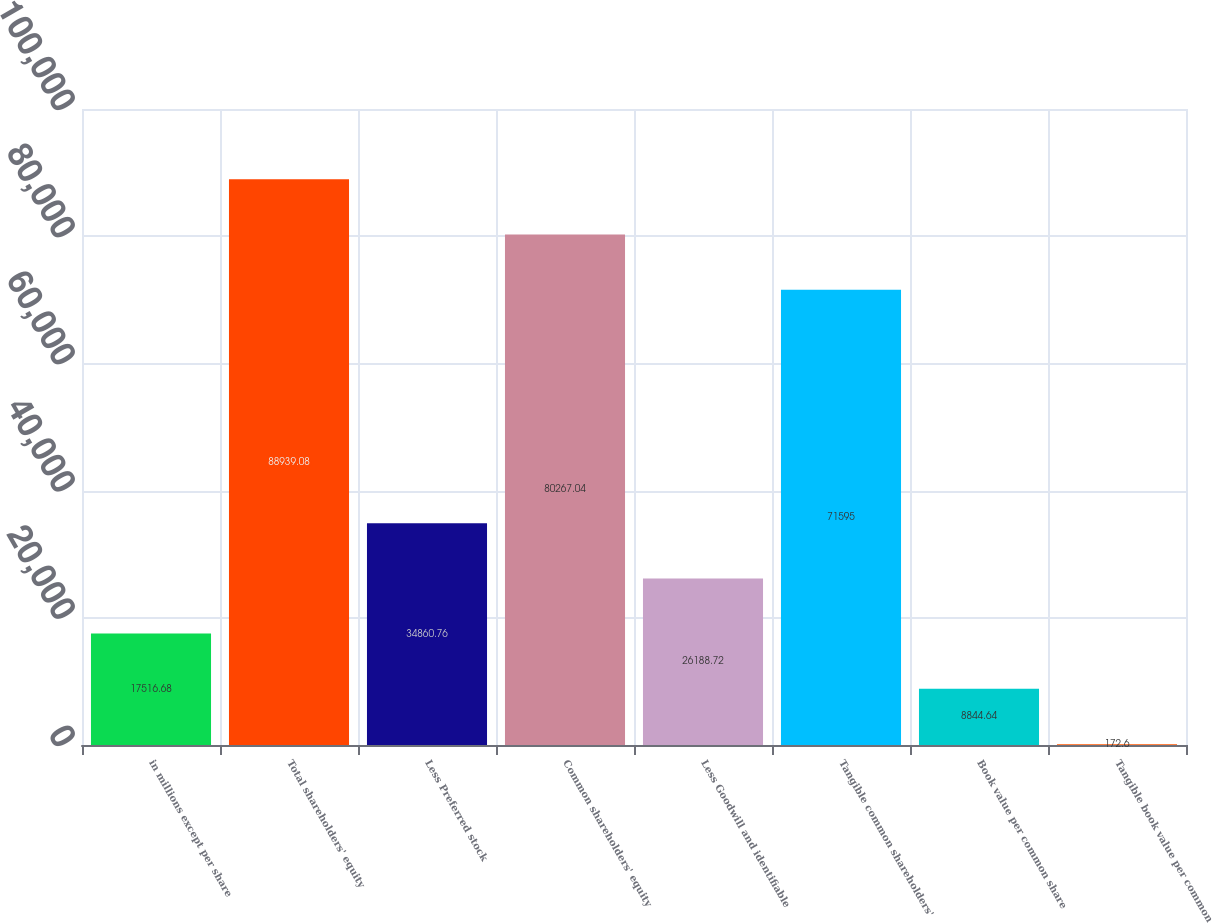Convert chart. <chart><loc_0><loc_0><loc_500><loc_500><bar_chart><fcel>in millions except per share<fcel>Total shareholders' equity<fcel>Less Preferred stock<fcel>Common shareholders' equity<fcel>Less Goodwill and identifiable<fcel>Tangible common shareholders'<fcel>Book value per common share<fcel>Tangible book value per common<nl><fcel>17516.7<fcel>88939.1<fcel>34860.8<fcel>80267<fcel>26188.7<fcel>71595<fcel>8844.64<fcel>172.6<nl></chart> 